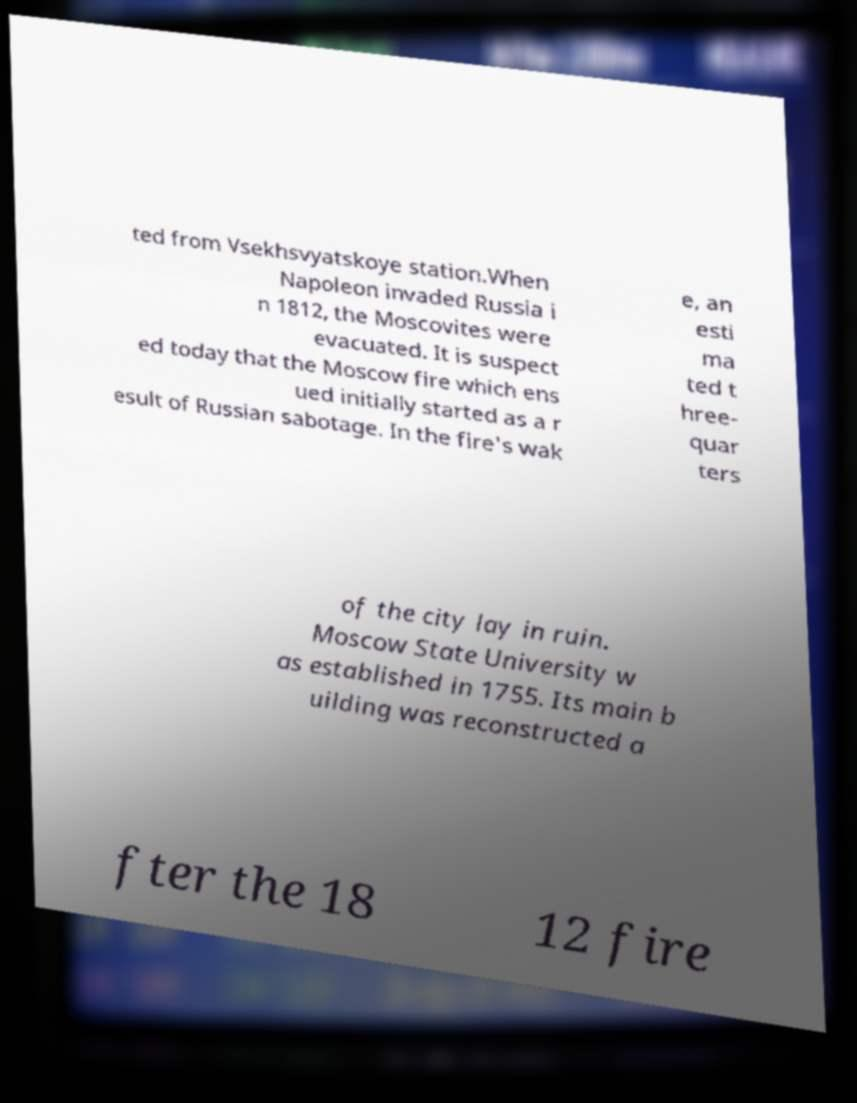Can you read and provide the text displayed in the image?This photo seems to have some interesting text. Can you extract and type it out for me? ted from Vsekhsvyatskoye station.When Napoleon invaded Russia i n 1812, the Moscovites were evacuated. It is suspect ed today that the Moscow fire which ens ued initially started as a r esult of Russian sabotage. In the fire's wak e, an esti ma ted t hree- quar ters of the city lay in ruin. Moscow State University w as established in 1755. Its main b uilding was reconstructed a fter the 18 12 fire 